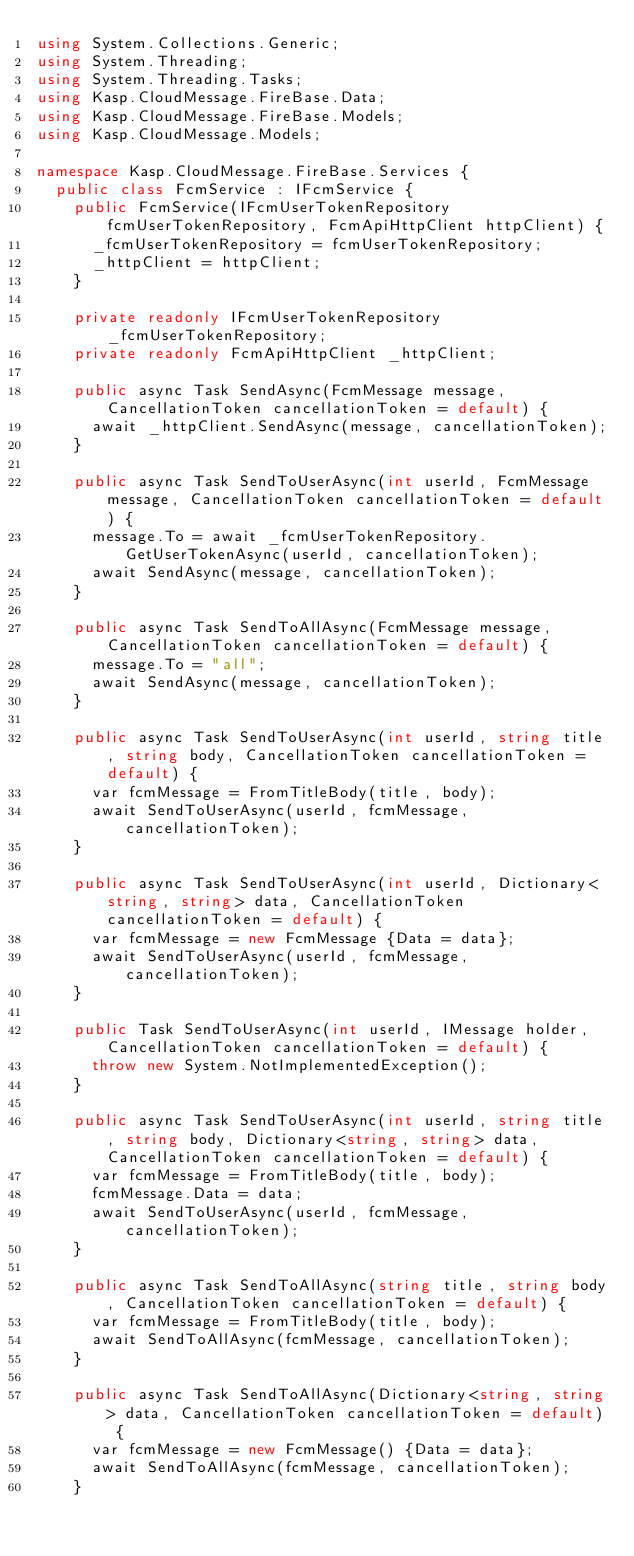Convert code to text. <code><loc_0><loc_0><loc_500><loc_500><_C#_>using System.Collections.Generic;
using System.Threading;
using System.Threading.Tasks;
using Kasp.CloudMessage.FireBase.Data;
using Kasp.CloudMessage.FireBase.Models;
using Kasp.CloudMessage.Models;

namespace Kasp.CloudMessage.FireBase.Services {
	public class FcmService : IFcmService {
		public FcmService(IFcmUserTokenRepository fcmUserTokenRepository, FcmApiHttpClient httpClient) {
			_fcmUserTokenRepository = fcmUserTokenRepository;
			_httpClient = httpClient;
		}

		private readonly IFcmUserTokenRepository _fcmUserTokenRepository;
		private readonly FcmApiHttpClient _httpClient;

		public async Task SendAsync(FcmMessage message, CancellationToken cancellationToken = default) {
			await _httpClient.SendAsync(message, cancellationToken);
		}

		public async Task SendToUserAsync(int userId, FcmMessage message, CancellationToken cancellationToken = default) {
			message.To = await _fcmUserTokenRepository.GetUserTokenAsync(userId, cancellationToken);
			await SendAsync(message, cancellationToken);
		}

		public async Task SendToAllAsync(FcmMessage message, CancellationToken cancellationToken = default) {
			message.To = "all";
			await SendAsync(message, cancellationToken);
		}

		public async Task SendToUserAsync(int userId, string title, string body, CancellationToken cancellationToken = default) {
			var fcmMessage = FromTitleBody(title, body);
			await SendToUserAsync(userId, fcmMessage, cancellationToken);
		}

		public async Task SendToUserAsync(int userId, Dictionary<string, string> data, CancellationToken cancellationToken = default) {
			var fcmMessage = new FcmMessage {Data = data};
			await SendToUserAsync(userId, fcmMessage, cancellationToken);
		}

		public Task SendToUserAsync(int userId, IMessage holder, CancellationToken cancellationToken = default) {
			throw new System.NotImplementedException();
		}

		public async Task SendToUserAsync(int userId, string title, string body, Dictionary<string, string> data, CancellationToken cancellationToken = default) {
			var fcmMessage = FromTitleBody(title, body);
			fcmMessage.Data = data;
			await SendToUserAsync(userId, fcmMessage, cancellationToken);
		}

		public async Task SendToAllAsync(string title, string body, CancellationToken cancellationToken = default) {
			var fcmMessage = FromTitleBody(title, body);
			await SendToAllAsync(fcmMessage, cancellationToken);
		}

		public async Task SendToAllAsync(Dictionary<string, string> data, CancellationToken cancellationToken = default) {
			var fcmMessage = new FcmMessage() {Data = data};
			await SendToAllAsync(fcmMessage, cancellationToken);
		}
</code> 